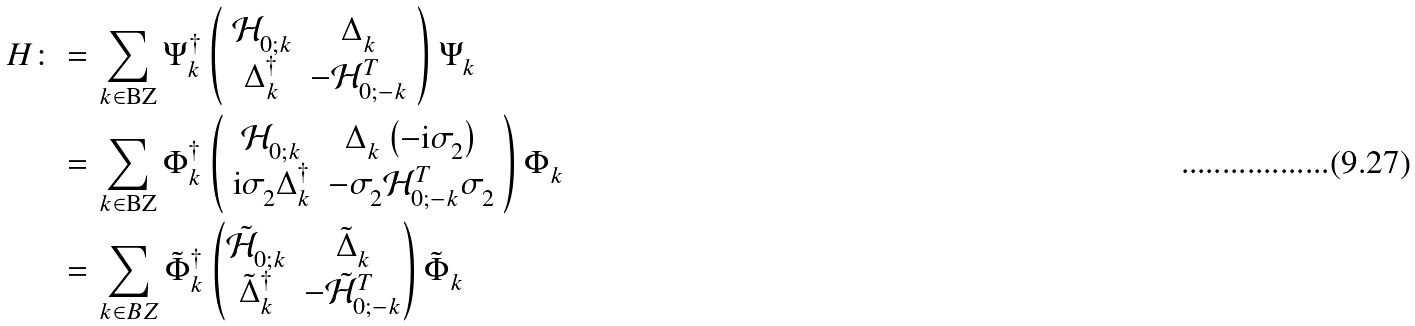Convert formula to latex. <formula><loc_0><loc_0><loc_500><loc_500>H \colon = & \, \sum _ { k \in \text {BZ} } \Psi ^ { \dag } _ { k } \left ( \begin{array} { c c } \mathcal { H } ^ { \ } _ { 0 ; k } & \Delta ^ { \ } _ { k } \\ \Delta ^ { \dag } _ { k } & - \mathcal { H } ^ { T } _ { 0 ; - k } \end{array} \right ) \Psi ^ { \ } _ { k } \\ = & \, \sum _ { k \in \text {BZ} } \Phi ^ { \dag } _ { k } \left ( \begin{array} { c c } \mathcal { H } ^ { \ } _ { 0 ; k } & \Delta ^ { \ } _ { k } \left ( - \text {i} \sigma ^ { \ } _ { 2 } \right ) \\ \text {i} \sigma ^ { \ } _ { 2 } \Delta ^ { \dag } _ { k } & - \sigma ^ { \ } _ { 2 } \mathcal { H } ^ { T } _ { 0 ; - k } \sigma ^ { \ } _ { 2 } \end{array} \right ) \Phi ^ { \ } _ { k } \\ = & \, \sum _ { k \in B Z } \tilde { \Phi } ^ { \dag } _ { k } \begin{pmatrix} \tilde { \mathcal { H } } ^ { \ } _ { 0 ; k } & \tilde { \Delta } ^ { \ } _ { k } \\ \tilde { \Delta } ^ { \dag } _ { k } & - \tilde { \mathcal { H } } ^ { T } _ { 0 ; - k } \end{pmatrix} \tilde { \Phi } ^ { \ } _ { k }</formula> 